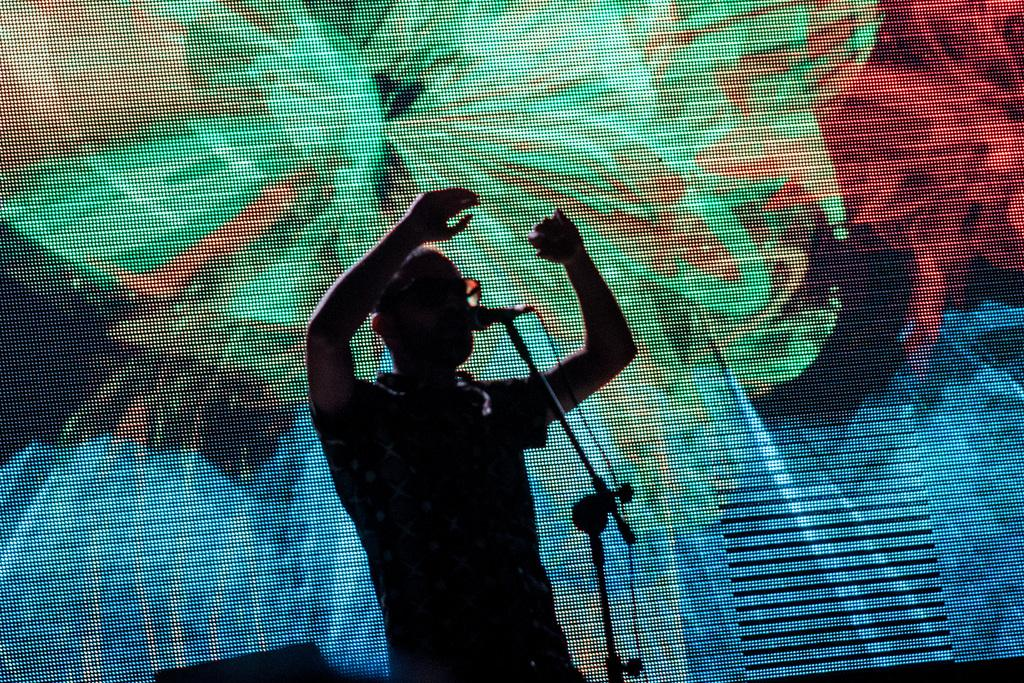What is the main subject in the image? There is a person standing in the image. What object is the person using in the image? There is a tripod in the image, and a microphone is present on the tripod. Can you describe the wire visible in the image? There is a wire visible in the image, but its purpose or origin is not clear. What can be seen in the background of the image? There is a screen in the background of the image, and it is colorful. What type of popcorn is being sold near the screen in the image? There is no popcorn present in the image, and no indication of any food being sold. How much profit is the person making from the event in the image? There is no information about the person's profit or any event in the image. 